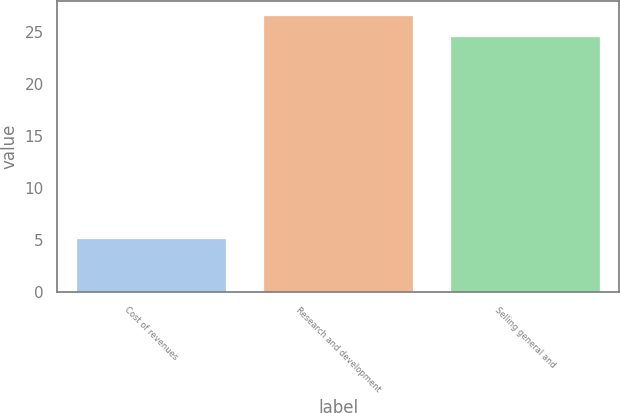Convert chart. <chart><loc_0><loc_0><loc_500><loc_500><bar_chart><fcel>Cost of revenues<fcel>Research and development<fcel>Selling general and<nl><fcel>5.2<fcel>26.66<fcel>24.6<nl></chart> 